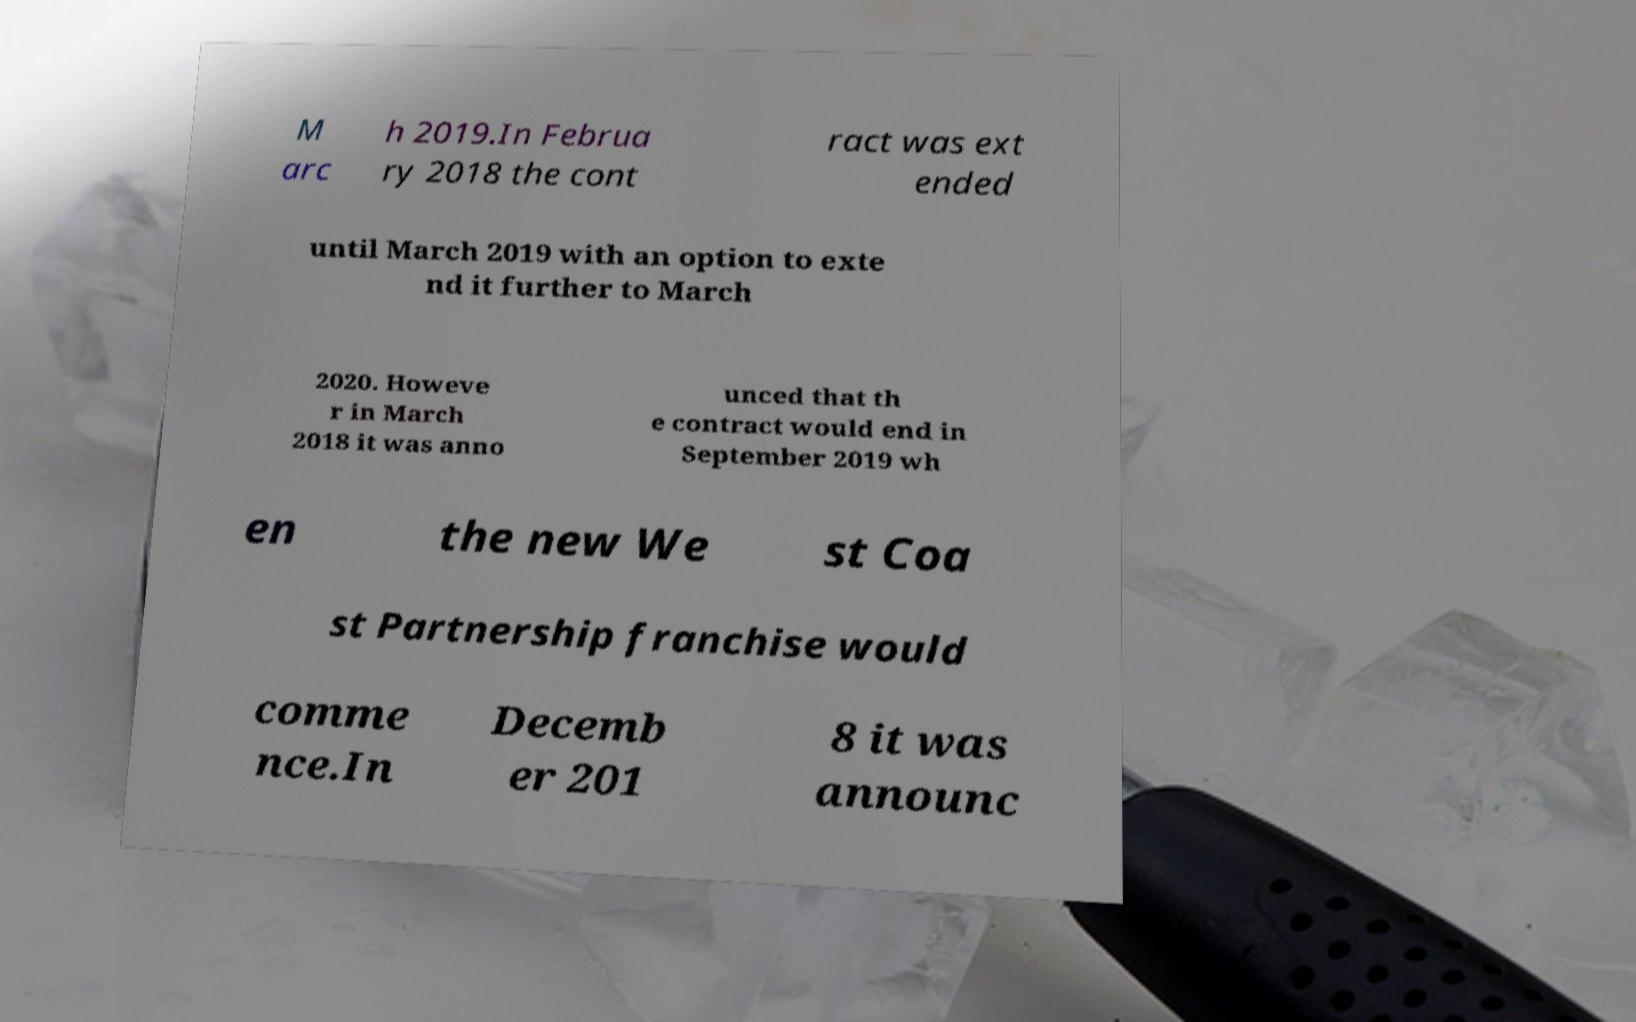Could you extract and type out the text from this image? M arc h 2019.In Februa ry 2018 the cont ract was ext ended until March 2019 with an option to exte nd it further to March 2020. Howeve r in March 2018 it was anno unced that th e contract would end in September 2019 wh en the new We st Coa st Partnership franchise would comme nce.In Decemb er 201 8 it was announc 